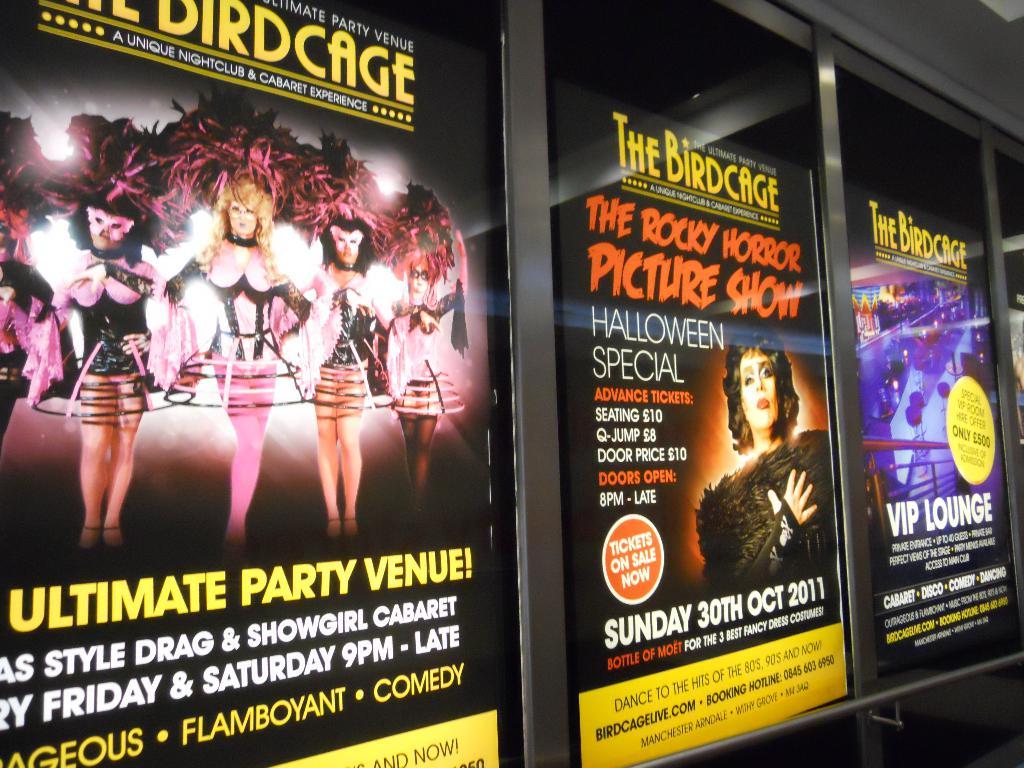What is the name of the show in the middle?
Offer a terse response. The rocky horror picture show. What kind of venue is the poster on the left advertising?
Provide a short and direct response. Ultimate party. 